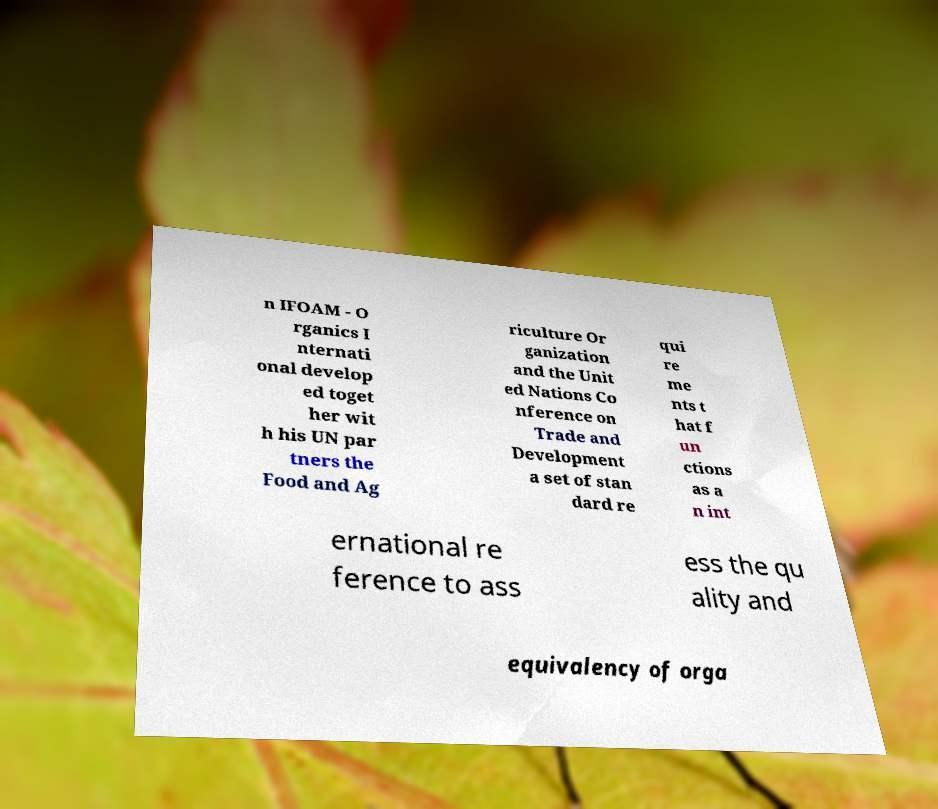Please identify and transcribe the text found in this image. n IFOAM - O rganics I nternati onal develop ed toget her wit h his UN par tners the Food and Ag riculture Or ganization and the Unit ed Nations Co nference on Trade and Development a set of stan dard re qui re me nts t hat f un ctions as a n int ernational re ference to ass ess the qu ality and equivalency of orga 